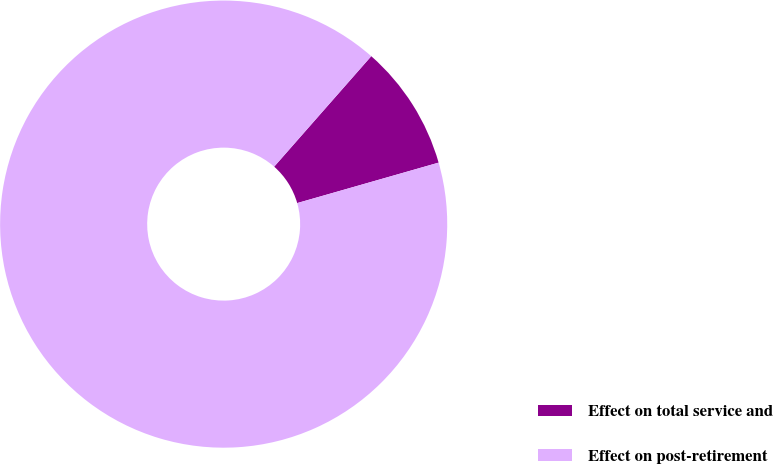<chart> <loc_0><loc_0><loc_500><loc_500><pie_chart><fcel>Effect on total service and<fcel>Effect on post-retirement<nl><fcel>9.09%<fcel>90.91%<nl></chart> 